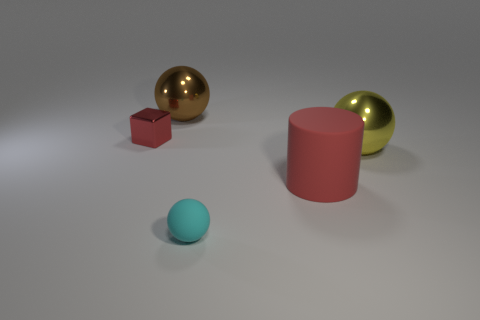Is there a shiny thing of the same color as the big matte cylinder?
Your answer should be compact. Yes. There is a matte object that is in front of the red rubber object; does it have the same size as the tiny metallic cube?
Ensure brevity in your answer.  Yes. Is the number of yellow things to the left of the red shiny thing the same as the number of small cyan rubber cylinders?
Your answer should be very brief. Yes. What number of objects are small red metal blocks that are to the left of the large rubber object or large brown shiny things?
Provide a short and direct response. 2. What shape is the metallic object that is both on the left side of the yellow metallic ball and on the right side of the tiny block?
Your answer should be compact. Sphere. What number of things are either metallic spheres that are in front of the tiny red cube or shiny balls that are right of the small cyan sphere?
Give a very brief answer. 1. What number of other things are there of the same size as the cyan sphere?
Offer a terse response. 1. There is a tiny metal block to the left of the large red cylinder; is its color the same as the big matte thing?
Keep it short and to the point. Yes. How big is the metal object that is in front of the brown metallic ball and on the left side of the small cyan rubber thing?
Provide a short and direct response. Small. What number of small objects are yellow metallic things or yellow rubber cylinders?
Offer a very short reply. 0. 